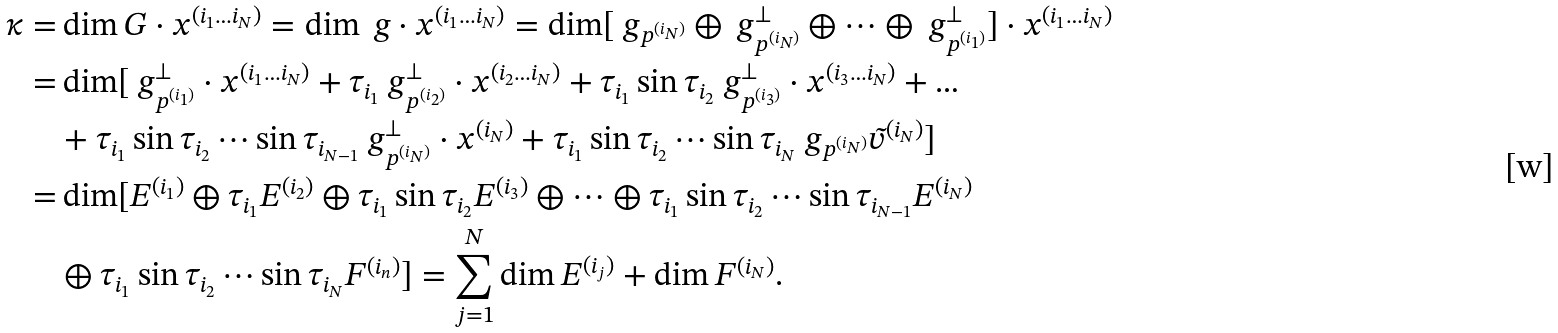Convert formula to latex. <formula><loc_0><loc_0><loc_500><loc_500>\kappa = & \dim G \cdot x ^ { ( i _ { 1 } \dots i _ { N } ) } = \dim \ g \cdot x ^ { ( i _ { 1 } \dots i _ { N } ) } = \dim [ \ g _ { p ^ { ( i _ { N } ) } } \oplus \ g _ { p ^ { ( i _ { N } ) } } ^ { \perp } \oplus \cdots \oplus \ g _ { p ^ { ( i _ { 1 } ) } } ^ { \perp } ] \cdot x ^ { ( i _ { 1 } \dots i _ { N } ) } \\ = & \dim [ \ g _ { p ^ { ( i _ { 1 } ) } } ^ { \perp } \cdot x ^ { ( i _ { 1 } \dots i _ { N } ) } + \tau _ { i _ { 1 } } \ g _ { p ^ { ( i _ { 2 } ) } } ^ { \perp } \cdot x ^ { ( i _ { 2 } \dots i _ { N } ) } + \tau _ { i _ { 1 } } \sin \tau _ { i _ { 2 } } \ g _ { p ^ { ( i _ { 3 } ) } } ^ { \perp } \cdot x ^ { ( i _ { 3 } \dots i _ { N } ) } + \dots \\ & + \tau _ { i _ { 1 } } \sin \tau _ { i _ { 2 } } \cdots \sin \tau _ { i _ { N - 1 } } \ g _ { p ^ { ( i _ { N } ) } } ^ { \perp } \cdot x ^ { ( i _ { N } ) } + \tau _ { i _ { 1 } } \sin \tau _ { i _ { 2 } } \cdots \sin \tau _ { i _ { N } } \ g _ { p ^ { ( i _ { N } ) } } \tilde { v } ^ { ( i _ { N } ) } ] \\ = & \dim [ E ^ { ( i _ { 1 } ) } \oplus \tau _ { i _ { 1 } } E ^ { ( i _ { 2 } ) } \oplus \tau _ { i _ { 1 } } \sin \tau _ { i _ { 2 } } E ^ { ( i _ { 3 } ) } \oplus \dots \oplus \tau _ { i _ { 1 } } \sin \tau _ { i _ { 2 } } \cdots \sin \tau _ { i _ { N - 1 } } E ^ { ( i _ { N } ) } \\ & \oplus \tau _ { i _ { 1 } } \sin \tau _ { i _ { 2 } } \cdots \sin \tau _ { i _ { N } } F ^ { ( i _ { n } ) } ] = \sum _ { j = 1 } ^ { N } \dim E ^ { ( i _ { j } ) } + \dim F ^ { ( i _ { N } ) } .</formula> 